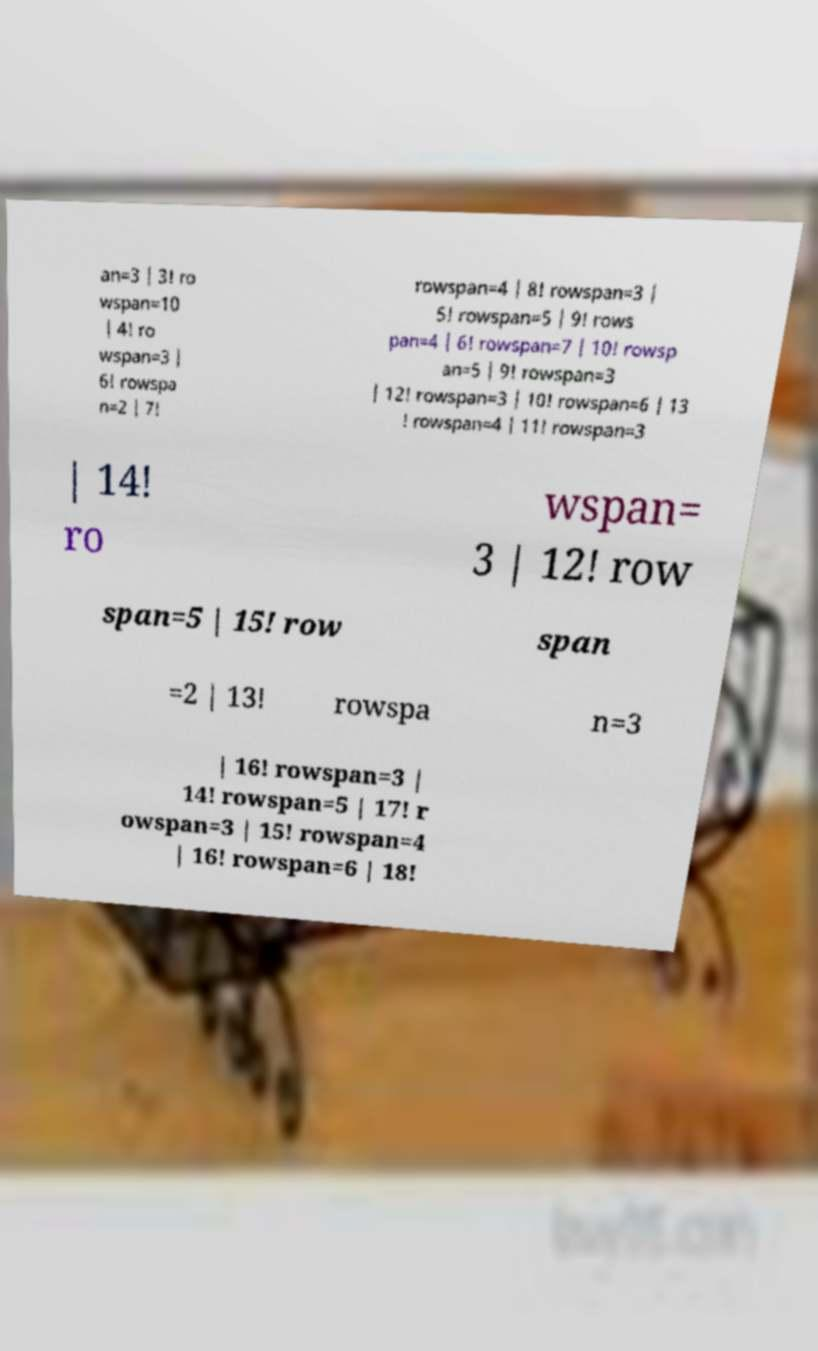Can you read and provide the text displayed in the image?This photo seems to have some interesting text. Can you extract and type it out for me? an=3 | 3! ro wspan=10 | 4! ro wspan=3 | 6! rowspa n=2 | 7! rowspan=4 | 8! rowspan=3 | 5! rowspan=5 | 9! rows pan=4 | 6! rowspan=7 | 10! rowsp an=5 | 9! rowspan=3 | 12! rowspan=3 | 10! rowspan=6 | 13 ! rowspan=4 | 11! rowspan=3 | 14! ro wspan= 3 | 12! row span=5 | 15! row span =2 | 13! rowspa n=3 | 16! rowspan=3 | 14! rowspan=5 | 17! r owspan=3 | 15! rowspan=4 | 16! rowspan=6 | 18! 